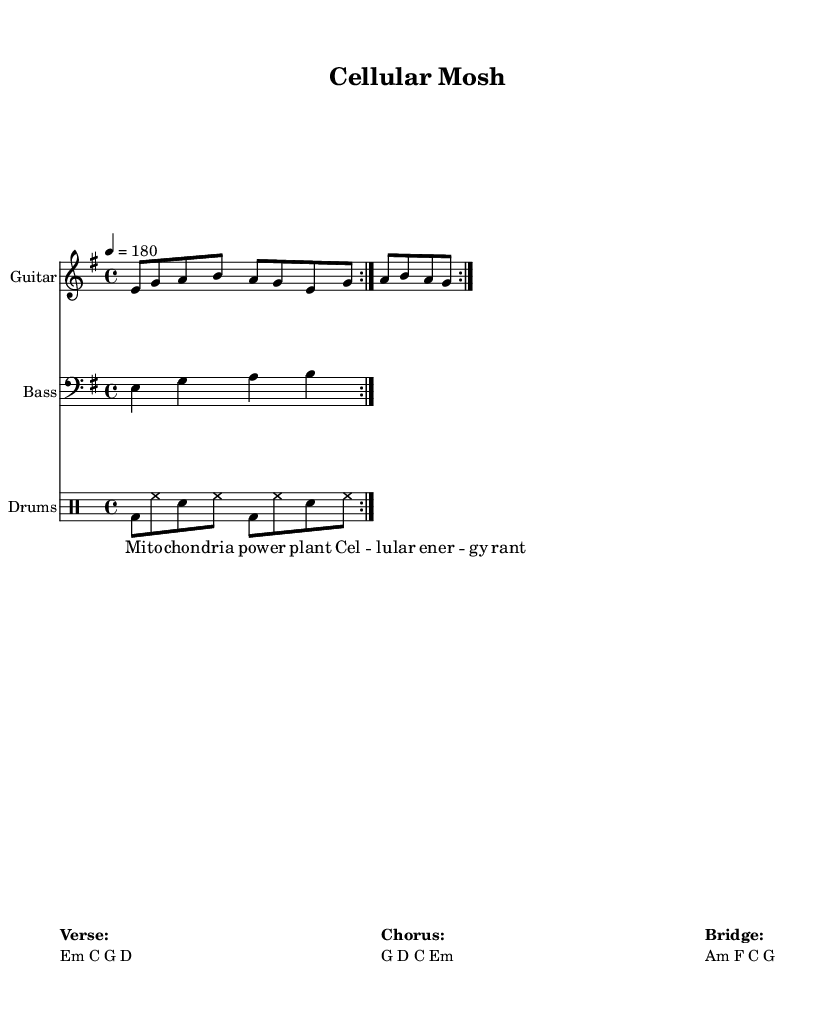What is the key signature of this music? The key signature has 1 sharp, indicating it is in E minor, which is the relative minor of G major. The sheet lists "E minor" under the global music settings.
Answer: E minor What is the time signature? The time signature is indicated at the beginning of the score, showing there are four beats per measure, which is presented as "4/4".
Answer: 4/4 What is the tempo marking of the music? The tempo is indicated at the beginning of the score with "4 = 180", meaning it should be played at 180 beats per minute.
Answer: 180 How many times is the guitar riff repeated? The sheet specifies a repeated section with "volta 2", which means the guitar riff is played twice consecutively.
Answer: 2 What chords are used in the verse? The chords shown with a bold label "Verse:" in the markup section are Em, C, G, D. These are read directly from the labeled column under the verse section.
Answer: Em, C, G, D What is the predominant theme conveyed in the lyrics? The lyrics mention "Mitochondria", a key component in cellular energy production, which aligns with the science theme, indicating a focus on cellular biology in this song. This is derived from the clear connection between the lyrics provided and the science concept they describe.
Answer: Cellular biology 